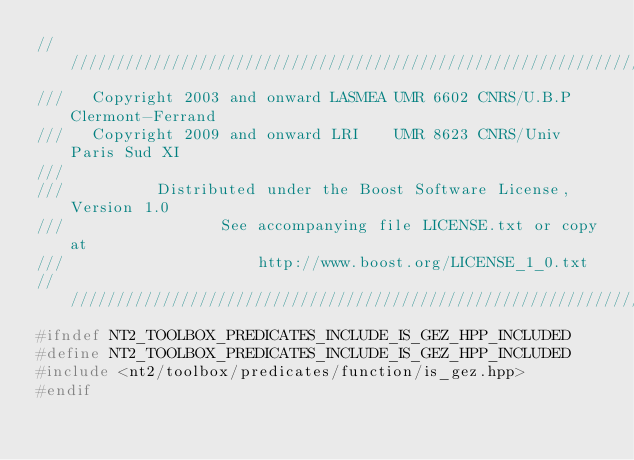Convert code to text. <code><loc_0><loc_0><loc_500><loc_500><_C++_>//////////////////////////////////////////////////////////////////////////////
///   Copyright 2003 and onward LASMEA UMR 6602 CNRS/U.B.P Clermont-Ferrand
///   Copyright 2009 and onward LRI    UMR 8623 CNRS/Univ Paris Sud XI
///
///          Distributed under the Boost Software License, Version 1.0
///                 See accompanying file LICENSE.txt or copy at
///                     http://www.boost.org/LICENSE_1_0.txt
//////////////////////////////////////////////////////////////////////////////
#ifndef NT2_TOOLBOX_PREDICATES_INCLUDE_IS_GEZ_HPP_INCLUDED
#define NT2_TOOLBOX_PREDICATES_INCLUDE_IS_GEZ_HPP_INCLUDED
#include <nt2/toolbox/predicates/function/is_gez.hpp>
#endif
</code> 